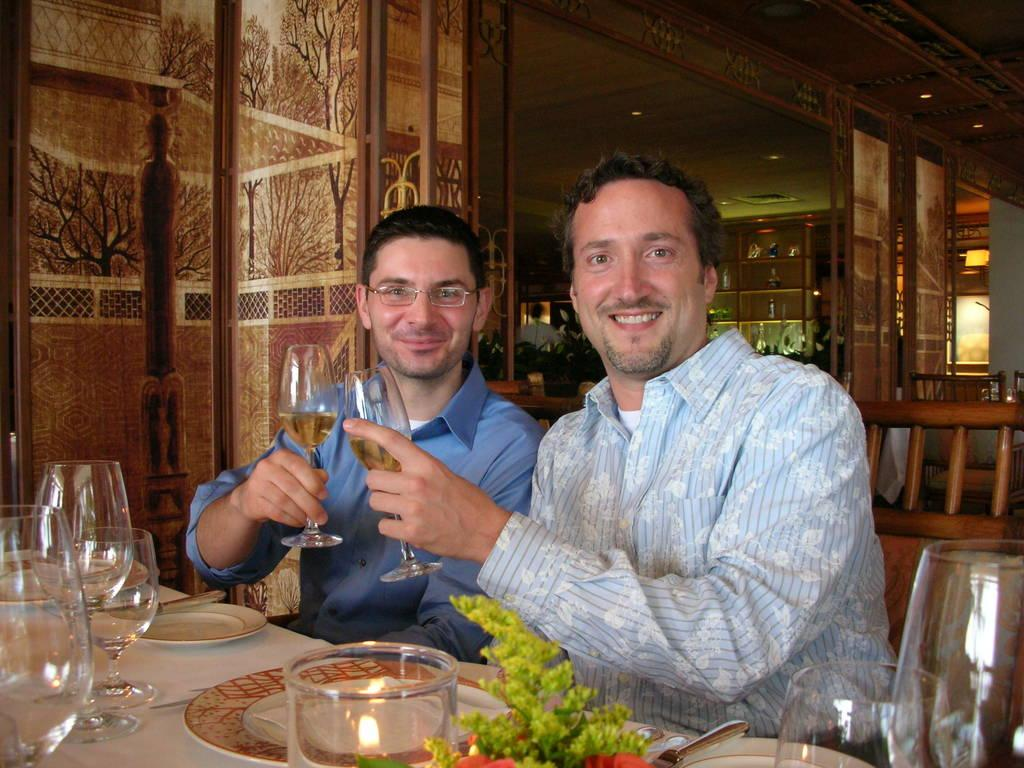How many people are in the image? There are two men in the image. What are the men doing in the image? The men are sitting and holding glasses. What expressions do the men have in the image? The men have smiles on their faces. What else can be seen on the table in the image? There are plates and additional glasses on the table. What color is the twig that the men are holding in the image? There is no twig present in the image; the men are holding glasses. How many trees can be seen in the image? There are no trees visible in the image. 